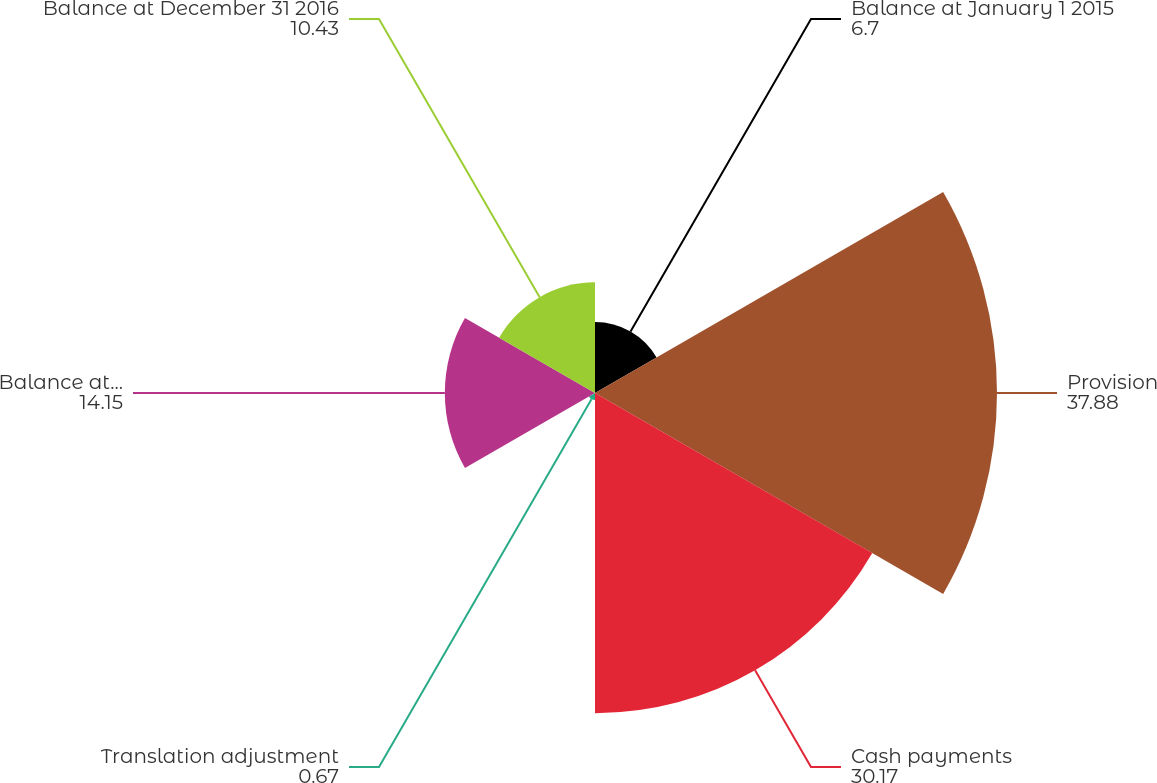Convert chart to OTSL. <chart><loc_0><loc_0><loc_500><loc_500><pie_chart><fcel>Balance at January 1 2015<fcel>Provision<fcel>Cash payments<fcel>Translation adjustment<fcel>Balance at December 31 2015<fcel>Balance at December 31 2016<nl><fcel>6.7%<fcel>37.88%<fcel>30.17%<fcel>0.67%<fcel>14.15%<fcel>10.43%<nl></chart> 